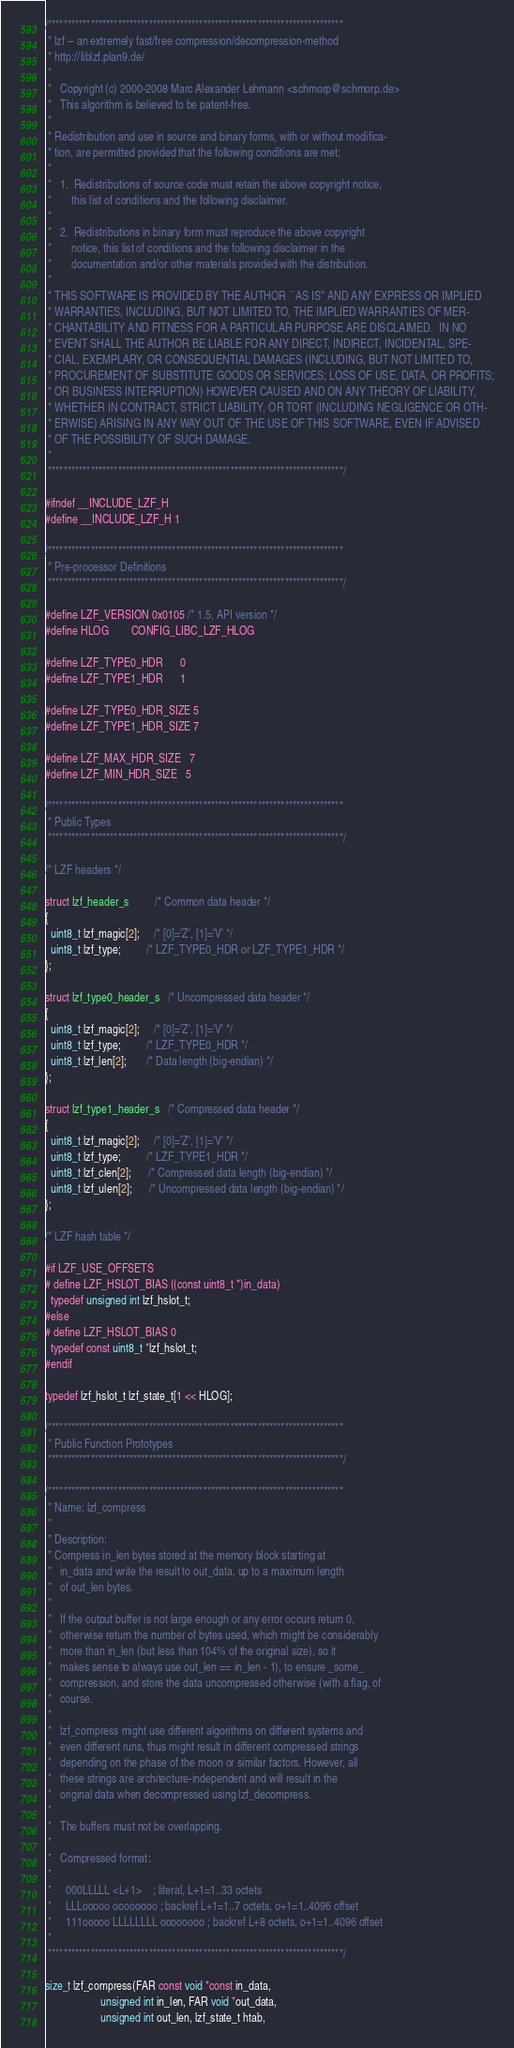Convert code to text. <code><loc_0><loc_0><loc_500><loc_500><_C_>/****************************************************************************
 * lzf -- an extremely fast/free compression/decompression-method
 * http://liblzf.plan9.de/
 *
 *   Copyright (c) 2000-2008 Marc Alexander Lehmann <schmorp@schmorp.de>
 *   This algorithm is believed to be patent-free.
 *
 * Redistribution and use in source and binary forms, with or without modifica-
 * tion, are permitted provided that the following conditions are met:
 *
 *   1.  Redistributions of source code must retain the above copyright notice,
 *       this list of conditions and the following disclaimer.
 *
 *   2.  Redistributions in binary form must reproduce the above copyright
 *       notice, this list of conditions and the following disclaimer in the
 *       documentation and/or other materials provided with the distribution.
 *
 * THIS SOFTWARE IS PROVIDED BY THE AUTHOR ``AS IS'' AND ANY EXPRESS OR IMPLIED
 * WARRANTIES, INCLUDING, BUT NOT LIMITED TO, THE IMPLIED WARRANTIES OF MER-
 * CHANTABILITY AND FITNESS FOR A PARTICULAR PURPOSE ARE DISCLAIMED.  IN NO
 * EVENT SHALL THE AUTHOR BE LIABLE FOR ANY DIRECT, INDIRECT, INCIDENTAL, SPE-
 * CIAL, EXEMPLARY, OR CONSEQUENTIAL DAMAGES (INCLUDING, BUT NOT LIMITED TO,
 * PROCUREMENT OF SUBSTITUTE GOODS OR SERVICES; LOSS OF USE, DATA, OR PROFITS;
 * OR BUSINESS INTERRUPTION) HOWEVER CAUSED AND ON ANY THEORY OF LIABILITY,
 * WHETHER IN CONTRACT, STRICT LIABILITY, OR TORT (INCLUDING NEGLIGENCE OR OTH-
 * ERWISE) ARISING IN ANY WAY OUT OF THE USE OF THIS SOFTWARE, EVEN IF ADVISED
 * OF THE POSSIBILITY OF SUCH DAMAGE.
 *
 ****************************************************************************/

#ifndef __INCLUDE_LZF_H
#define __INCLUDE_LZF_H 1

/****************************************************************************
 * Pre-processor Definitions
 ****************************************************************************/

#define LZF_VERSION 0x0105 /* 1.5, API version */
#define HLOG        CONFIG_LIBC_LZF_HLOG

#define LZF_TYPE0_HDR      0
#define LZF_TYPE1_HDR      1

#define LZF_TYPE0_HDR_SIZE 5
#define LZF_TYPE1_HDR_SIZE 7

#define LZF_MAX_HDR_SIZE   7
#define LZF_MIN_HDR_SIZE   5

/****************************************************************************
 * Public Types
 ****************************************************************************/

/* LZF headers */

struct lzf_header_s         /* Common data header */
{
  uint8_t lzf_magic[2];     /* [0]='Z', [1]='V' */
  uint8_t lzf_type;         /* LZF_TYPE0_HDR or LZF_TYPE1_HDR */
};

struct lzf_type0_header_s   /* Uncompressed data header */
{
  uint8_t lzf_magic[2];     /* [0]='Z', [1]='V' */
  uint8_t lzf_type;         /* LZF_TYPE0_HDR */
  uint8_t lzf_len[2];       /* Data length (big-endian) */
};

struct lzf_type1_header_s   /* Compressed data header */
{
  uint8_t lzf_magic[2];     /* [0]='Z', [1]='V' */
  uint8_t lzf_type;         /* LZF_TYPE1_HDR */
  uint8_t lzf_clen[2];      /* Compressed data length (big-endian) */
  uint8_t lzf_ulen[2];      /* Uncompressed data length (big-endian) */
};

/* LZF hash table */

#if LZF_USE_OFFSETS
# define LZF_HSLOT_BIAS ((const uint8_t *)in_data)
  typedef unsigned int lzf_hslot_t;
#else
# define LZF_HSLOT_BIAS 0
  typedef const uint8_t *lzf_hslot_t;
#endif

typedef lzf_hslot_t lzf_state_t[1 << HLOG];

/****************************************************************************
 * Public Function Prototypes
 ****************************************************************************/

/****************************************************************************
 * Name: lzf_compress
 *
 * Description:
 * Compress in_len bytes stored at the memory block starting at
 *   in_data and write the result to out_data, up to a maximum length
 *   of out_len bytes.
 *
 *   If the output buffer is not large enough or any error occurs return 0,
 *   otherwise return the number of bytes used, which might be considerably
 *   more than in_len (but less than 104% of the original size), so it
 *   makes sense to always use out_len == in_len - 1), to ensure _some_
 *   compression, and store the data uncompressed otherwise (with a flag, of
 *   course.
 *
 *   lzf_compress might use different algorithms on different systems and
 *   even different runs, thus might result in different compressed strings
 *   depending on the phase of the moon or similar factors. However, all
 *   these strings are architecture-independent and will result in the
 *   original data when decompressed using lzf_decompress.
 *
 *   The buffers must not be overlapping.
 *
 *   Compressed format:
 *
 *     000LLLLL <L+1>    ; literal, L+1=1..33 octets
 *     LLLooooo oooooooo ; backref L+1=1..7 octets, o+1=1..4096 offset
 *     111ooooo LLLLLLLL oooooooo ; backref L+8 octets, o+1=1..4096 offset
 *
 ****************************************************************************/

size_t lzf_compress(FAR const void *const in_data,
                    unsigned int in_len, FAR void *out_data,
                    unsigned int out_len, lzf_state_t htab,</code> 